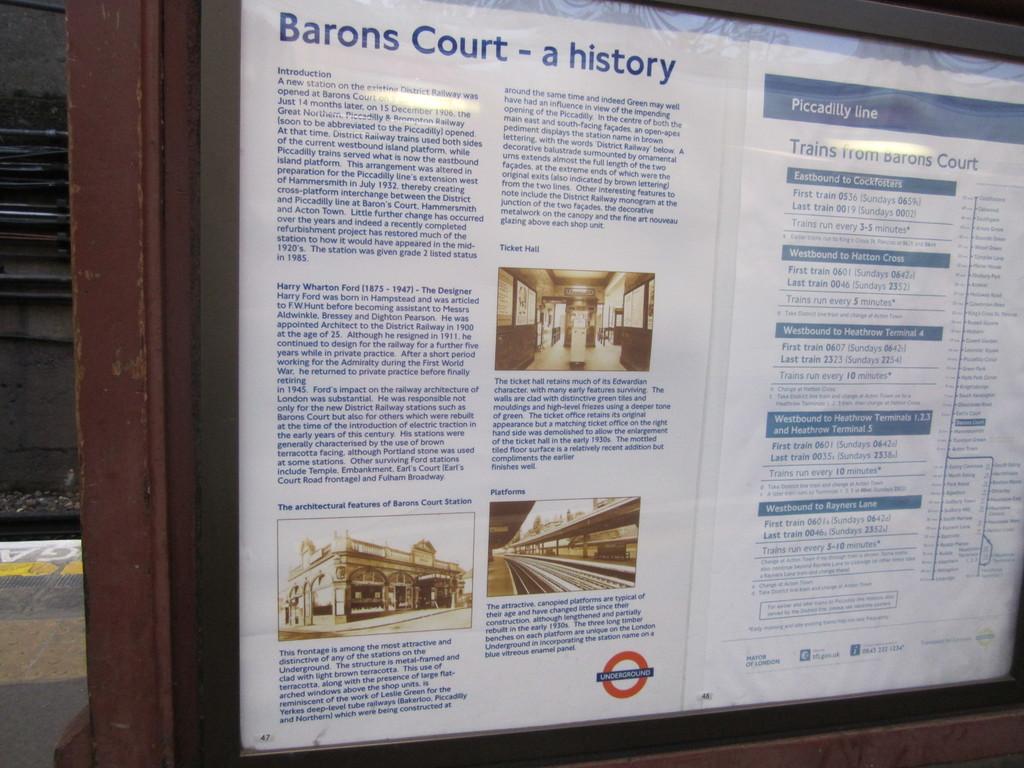Which line is this train station on?
Your response must be concise. Barons court. A history of what court?
Ensure brevity in your answer.  Barons court. 